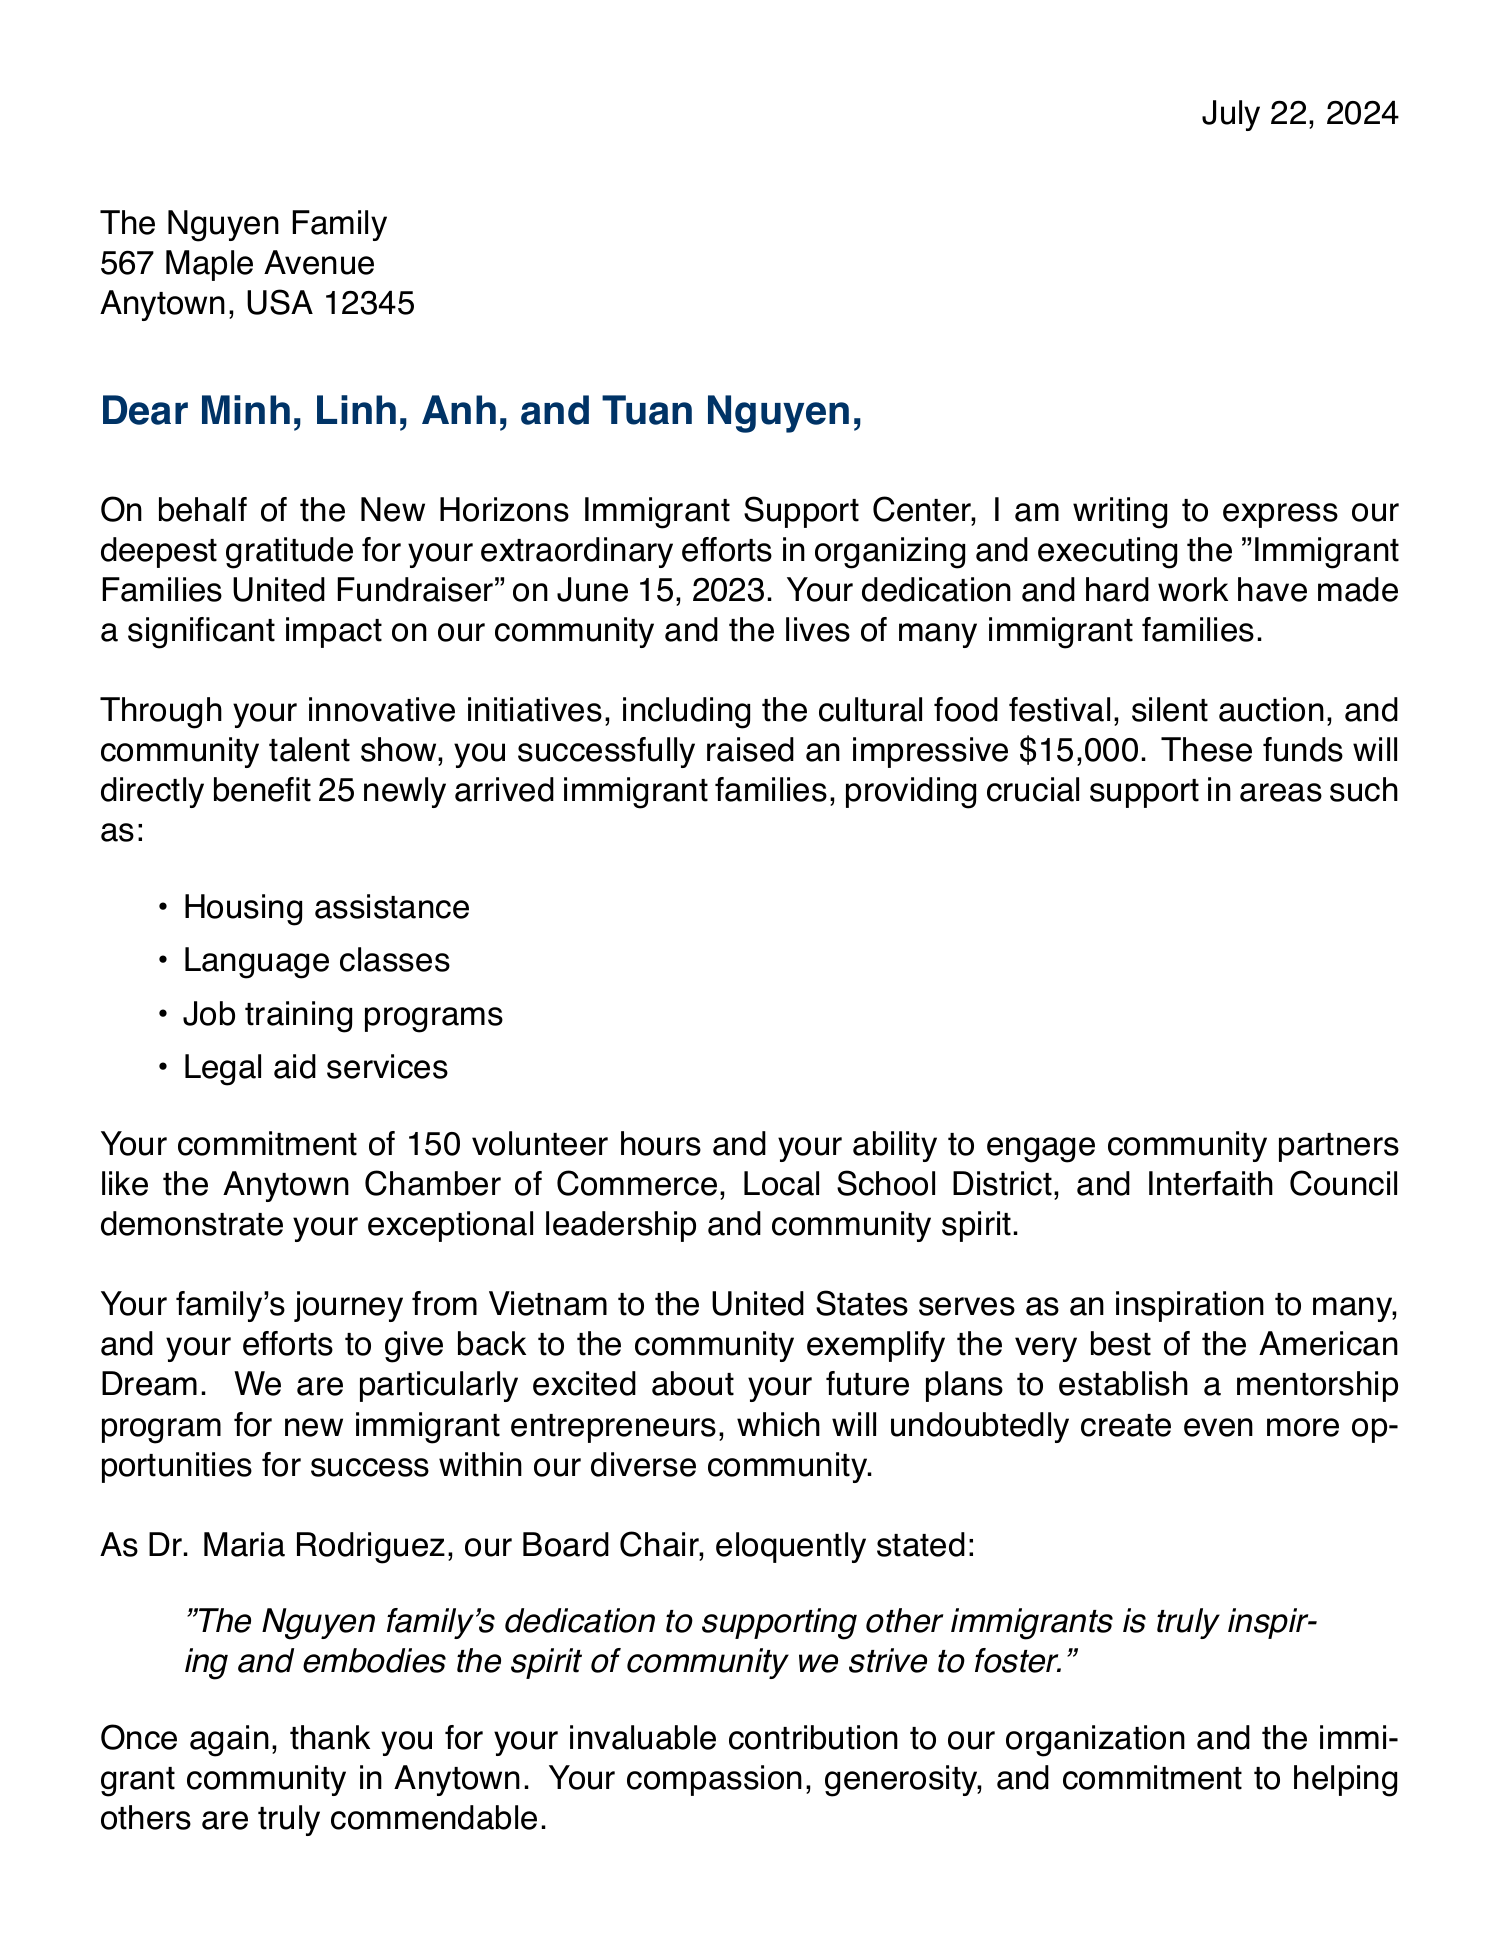what is the name of the organization? The organization that sent the letter is specified at the beginning of the document.
Answer: New Horizons Immigrant Support Center what is the family's last name? The document specifically addresses the family, and it notes their last name.
Answer: Nguyen when was the fundraiser held? The date of the event is clearly stated in the letter.
Answer: June 15, 2023 how much money was raised through the fundraiser? The total amount raised during the event is mentioned in the letter.
Answer: $15,000 how many immigrant families benefited from the funds? The letter states the number of families that received help from the fundraiser.
Answer: 25 what was one of the activities organized for the fundraiser? The document lists several contributions made by the family, including events.
Answer: cultural food festival who is the executive director of the organization? The letter concludes with the sign-off from the executive director, revealing their name.
Answer: James Thompson which community partner is mentioned in the letter? The letter lists several partners that worked with the family on the fundraiser.
Answer: Anytown Chamber of Commerce what future plan does the Nguyen family have? The letter discusses the family's ambitions for ongoing community support.
Answer: Mentorship program for new immigrant entrepreneurs 